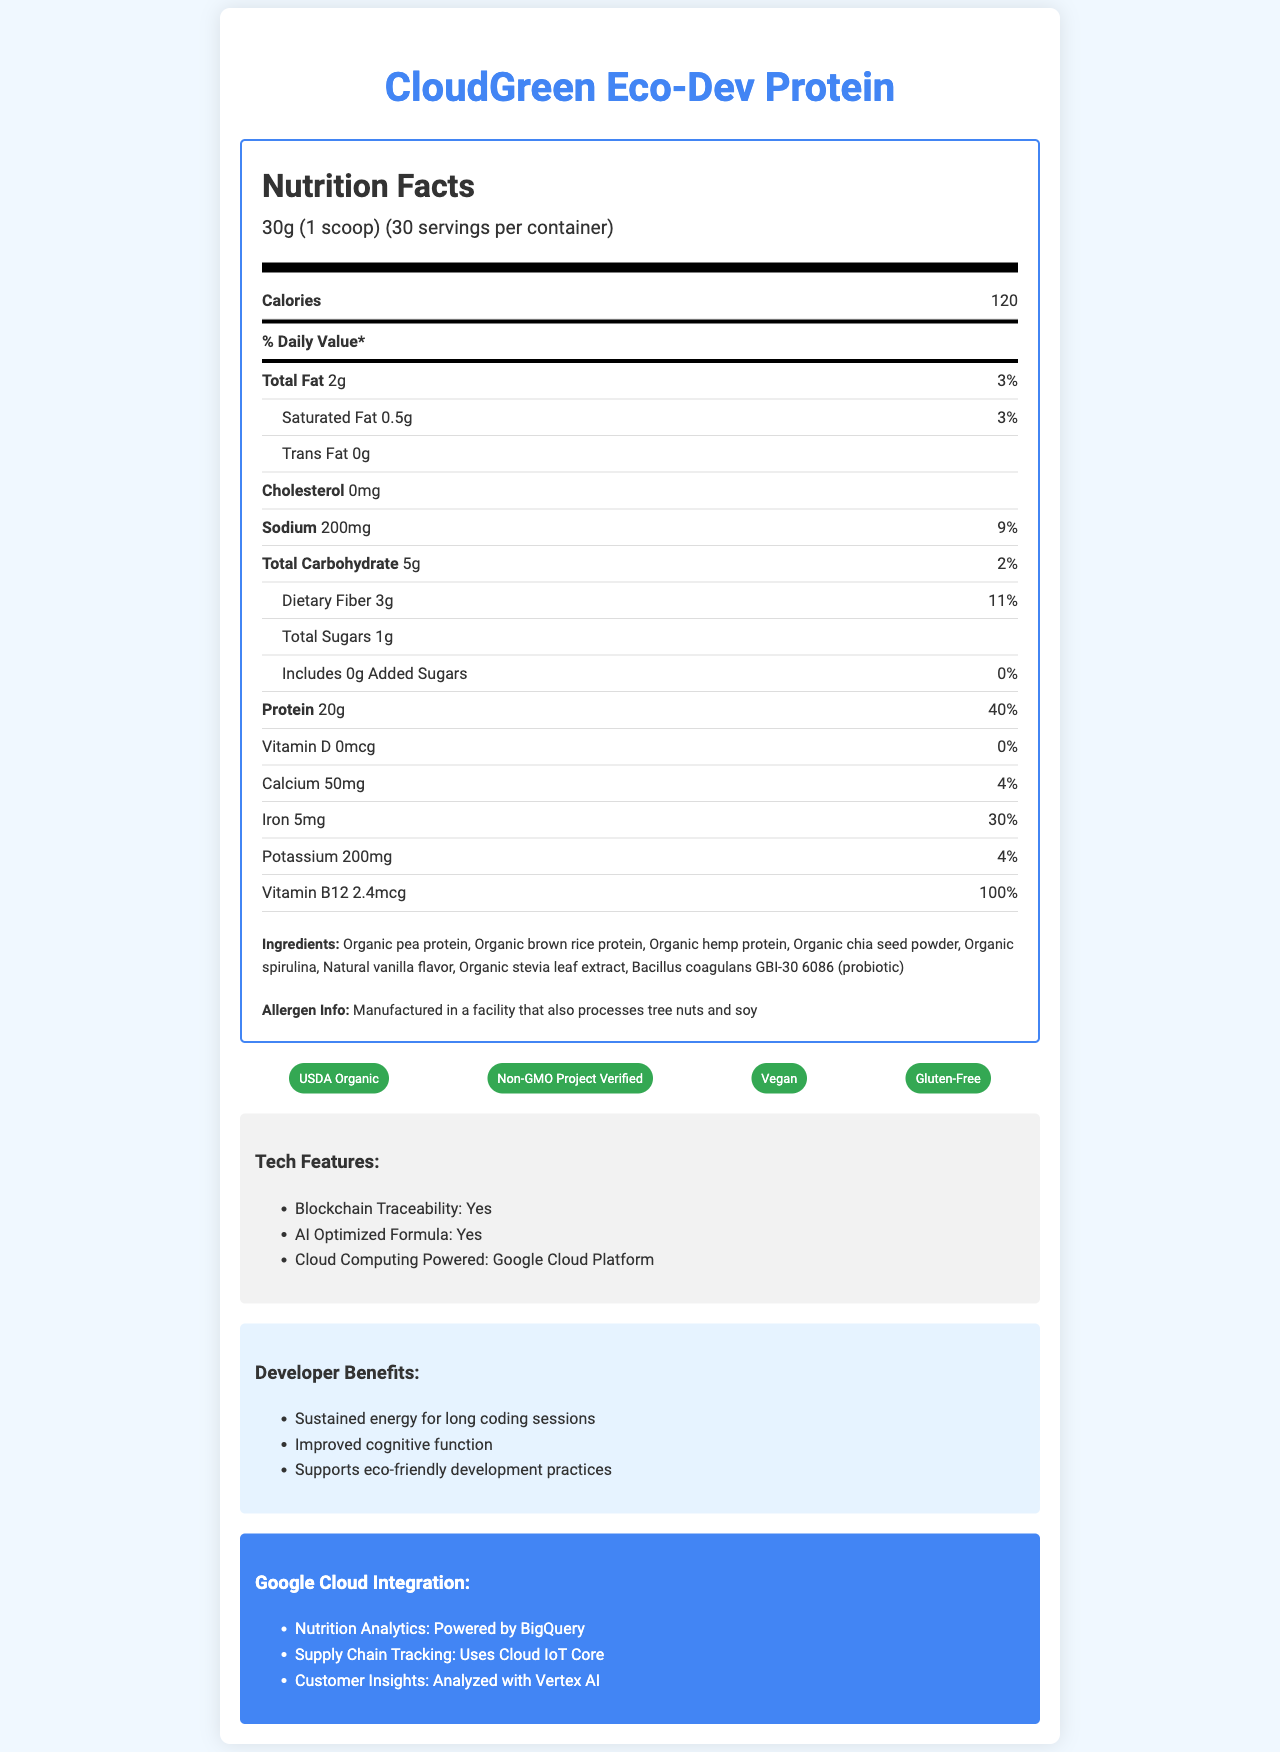What is the serving size of CloudGreen Eco-Dev Protein? The serving size is indicated at the top of the nutrition label.
Answer: 30g (1 scoop) How many calories are there in one serving? The calories per serving are mentioned in the "Calories" section of the nutrition label.
Answer: 120 What is the amount of protein per serving? The amount of protein is explicitly stated in the nutrition label in the "Protein" section.
Answer: 20g Name one of the plant-based protein ingredients in the product. One of the listed ingredients under the "Ingredients" section is organic pea protein.
Answer: Organic pea protein List two certifications that CloudGreen Eco-Dev Protein has received. The certifications are shown in the "Certifications" section and include USDA Organic and Non-GMO Project Verified among others.
Answer: USDA Organic, Non-GMO Project Verified What is the daily value percentage of iron per serving? A. 30% B. 40% C. 50% D. 60% The percentage daily value of iron is listed as 30% under the "Iron" section on the nutrition label.
Answer: A. 30% Which cloud platform is used for powering CloudGreen Eco-Dev Protein's cloud computing features? A. AWS B. Microsoft Azure C. Google Cloud Platform D. IBM Cloud The tech features section states that it is "Cloud Computing Powered: Google Cloud Platform."
Answer: C. Google Cloud Platform Does the product contain any added sugars? The nutrition label in the "Added Sugars" section shows that it includes 0g Added Sugars, which means none are present.
Answer: No Summarize the key aspects of CloudGreen Eco-Dev Protein based on the document. The document describes the product, detailing its nutritional content, ingredients, health certifications, environmental impact measures, tech features, developer benefits, and Google Cloud integrations.
Answer: CloudGreen Eco-Dev Protein is an eco-friendly plant-based protein powder designed for environmentally conscious developers. It features organic ingredients, is rich in protein, and has multiple health certifications. It supports blockchain traceability and AI-optimized formula, powered by Google Cloud Platform technologies, and provides sustained energy and cognitive benefits for long coding sessions. How many servings are there per container? At the top of the nutrition label, it specifies that there are 30 servings per container.
Answer: 30 What is the carbon footprint per serving? This information can be found in the "Environmental Impact" section.
Answer: 0.8 kg CO2e per serving What is the source of the probiotic added in the protein powder? The probiotic component is listed under the "Ingredients" section.
Answer: Bacillus coagulans GBI-30 6086 Is the product Gluten-Free? The "Certifications" section includes a Gluten-Free certification.
Answer: Yes What is the AI-optimized feature powered by? The "Tech Features" section mentions that the AI-optimized formula is powered by Google Cloud Platform.
Answer: Google Cloud Platform What is the total fat amount per serving and its daily value percentage? The "Total Fat" section of the nutrition label provides this amount and daily value.
Answer: 2g, 3% How much dietary fiber does one serving contain? The amount of dietary fiber per serving is specified in the "Dietary Fiber" section of the nutrition label.
Answer: 3g Describe CloudGreen Eco-Dev Protein’s developer benefits. The "Developer Benefits" section lists these benefits tailored to developers.
Answer: Sustained energy for long coding sessions, Improved cognitive function, Supports eco-friendly development practices Are the provided sources of nutrition analytics, supply chain tracking, and customer insights from Google Cloud? The "Google Cloud Integration" section specifies that these features are powered by Google Cloud services like BigQuery, Cloud IoT Core, and Vertex AI.
Answer: Yes Does the total carbohydrate amount include added sugars? The "Total Carbohydrate" section of the nutrition label specifies the total carbohydrate amount, with 0g added sugars clearly mentioned in the "Added Sugars" subsection.
Answer: No, it includes 0g added sugars What cannot be determined from the document about CloudGreen Eco-Dev Protein? The document does not provide any information about the pricing of CloudGreen Eco-Dev Protein.
Answer: The exact price of the product 